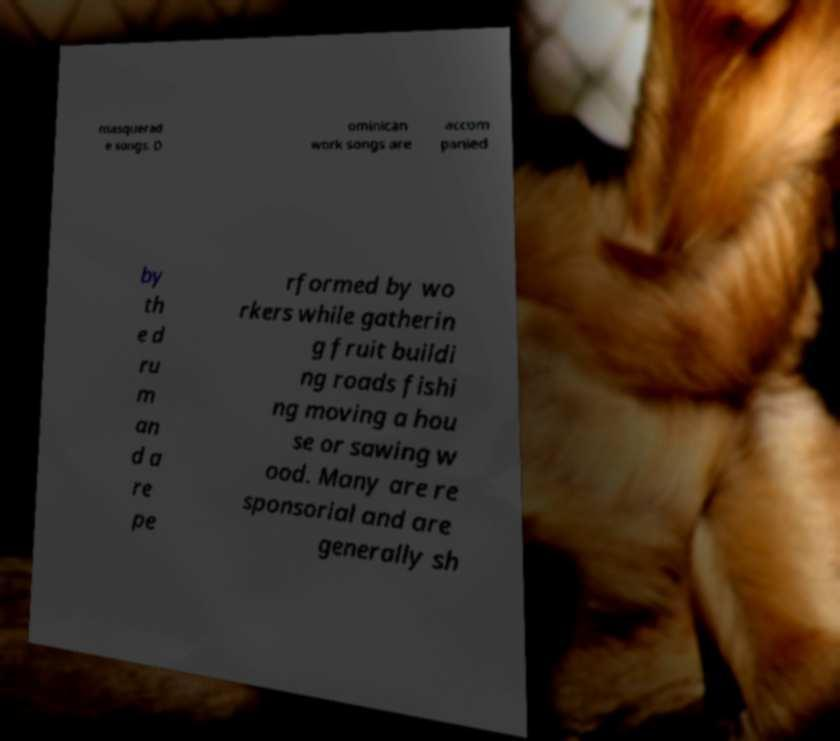Could you assist in decoding the text presented in this image and type it out clearly? masquerad e songs. D ominican work songs are accom panied by th e d ru m an d a re pe rformed by wo rkers while gatherin g fruit buildi ng roads fishi ng moving a hou se or sawing w ood. Many are re sponsorial and are generally sh 